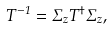<formula> <loc_0><loc_0><loc_500><loc_500>T ^ { - 1 } = \Sigma _ { z } T ^ { \dagger } \Sigma _ { z } ,</formula> 